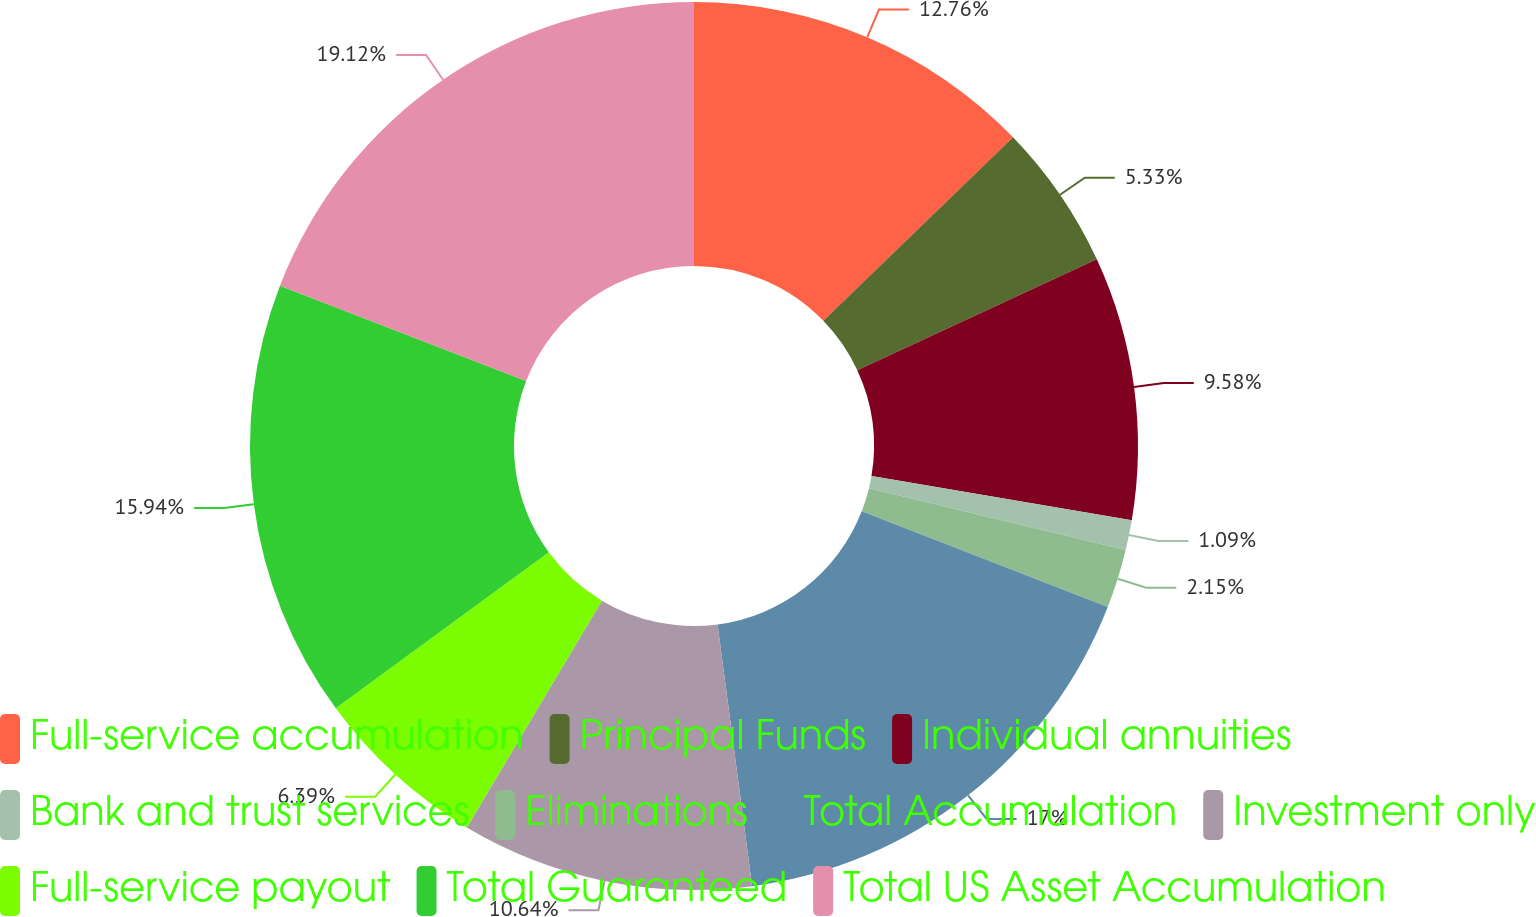<chart> <loc_0><loc_0><loc_500><loc_500><pie_chart><fcel>Full-service accumulation<fcel>Principal Funds<fcel>Individual annuities<fcel>Bank and trust services<fcel>Eliminations<fcel>Total Accumulation<fcel>Investment only<fcel>Full-service payout<fcel>Total Guaranteed<fcel>Total US Asset Accumulation<nl><fcel>12.76%<fcel>5.33%<fcel>9.58%<fcel>1.09%<fcel>2.15%<fcel>17.0%<fcel>10.64%<fcel>6.39%<fcel>15.94%<fcel>19.12%<nl></chart> 